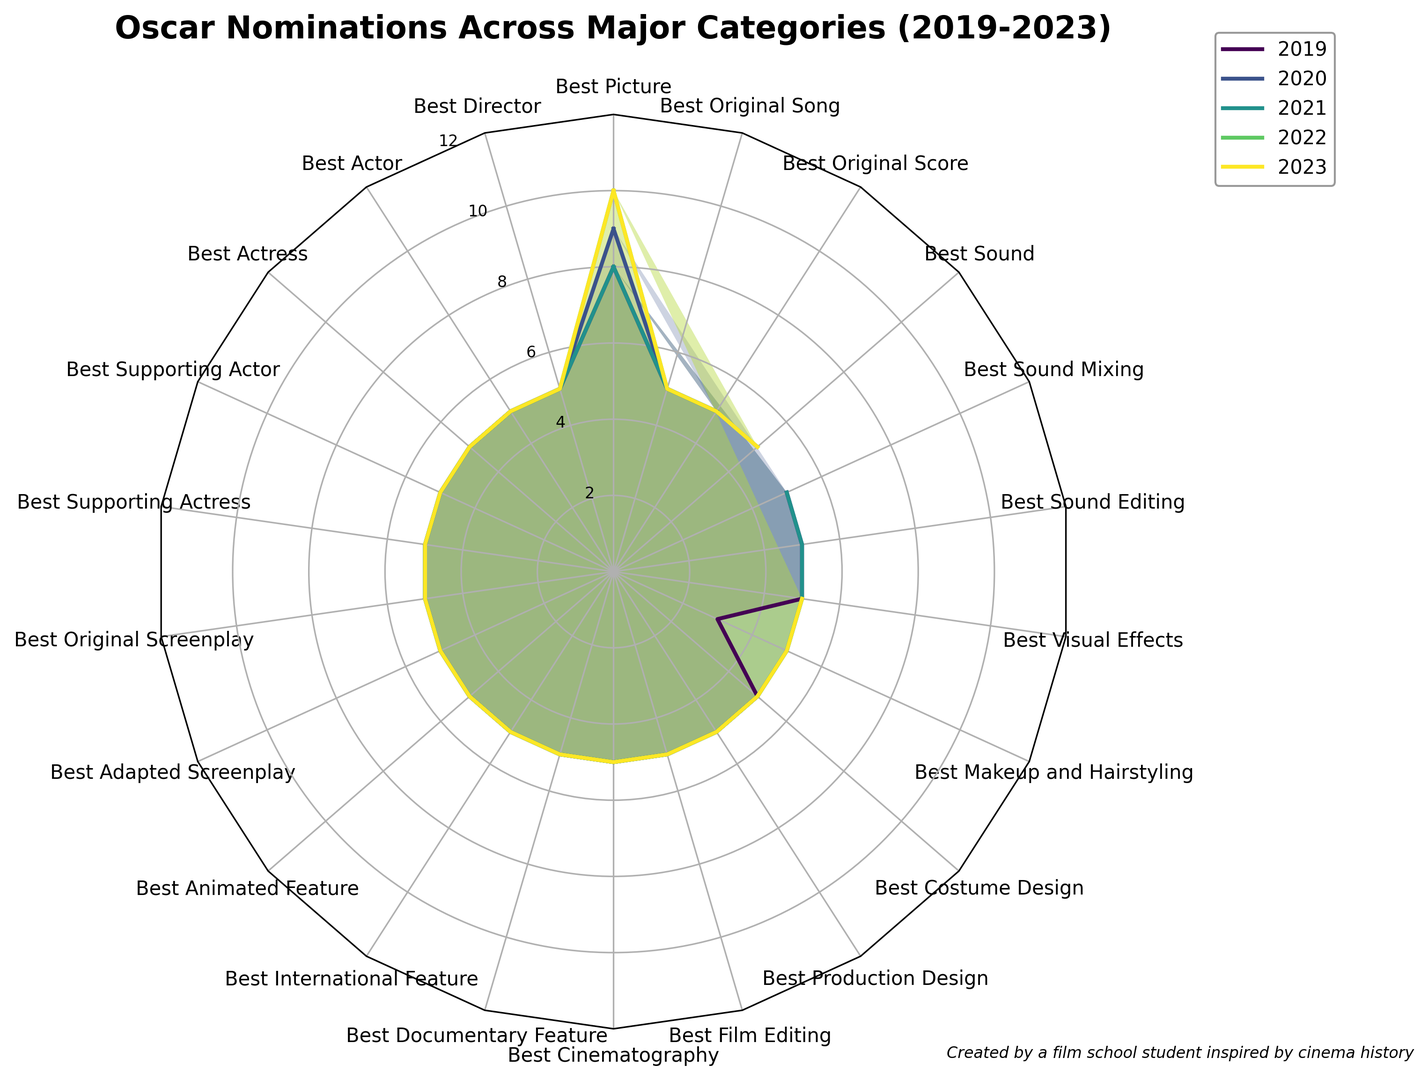What's the median number of nominations for 'Best Picture' from 2019 to 2023? To find the median, list the number of nominations from 2019 to 2023 for 'Best Picture': 8, 9, 8, 10, 10. Arrange them in order: 8, 8, 9, 10, 10. The median is the middle value, which is 9.
Answer: 9 Which year shows a unique pattern due to variations in 'Makeup and Hairstyling' category nominations? Observing the data, in 2019, 'Makeup and Hairstyling' had 3 nominations compared to 5 in other years. This creates a unique pattern for 2019.
Answer: 2019 Do any categories show a consistent number of nominations across all years? Yes, almost all categories except 'Best Picture', 'Best Makeup and Hairstyling', and 'Sound Editing/Sound Mixing' (due to merging) show consistent nominations across 2019 to 2023.
Answer: Yes Which years had the highest number of 'Best Picture' nominations? For 'Best Picture', the highest number of nominations occurred in 2022 and 2023 with 10 nominations each.
Answer: 2022 and 2023 How did the merging of 'Sound Editing' and 'Sound Mixing' affect nominations in 2022 and 2023? 'Sound Editing' and 'Sound Mixing' were separate categories until 2021. In 2022 and 2023, they were merged into 'Best Sound'. Both years show 5 nominations under 'Best Sound', which replaced the separate nominations.
Answer: They were merged into 'Best Sound' with 5 nominations Compare the nomination consistency between 'Best Director' and 'Best Picture' from 2019 to 2023. 'Best Director' consistently had 5 nominations each year, while 'Best Picture' varied (8, 9, 8, 10, and 10 nominations from 2019 to 2023).
Answer: 'Best Director' is consistent; 'Best Picture' varies Which category had the most nominations in a single year? 'Best Picture' had the most nominations in a single year, with 10 nominations in both 2022 and 2023.
Answer: Best Picture in 2022 and 2023 What is the trend for the number of categories that had exactly 5 nominations each year from 2019 to 2023? Except for 'Best Picture' and 'Best Makeup and Hairstyling', most categories had exactly 5 nominations. The trend remains consistent except for the merging of sound awards in 2022.
Answer: Stable trend 